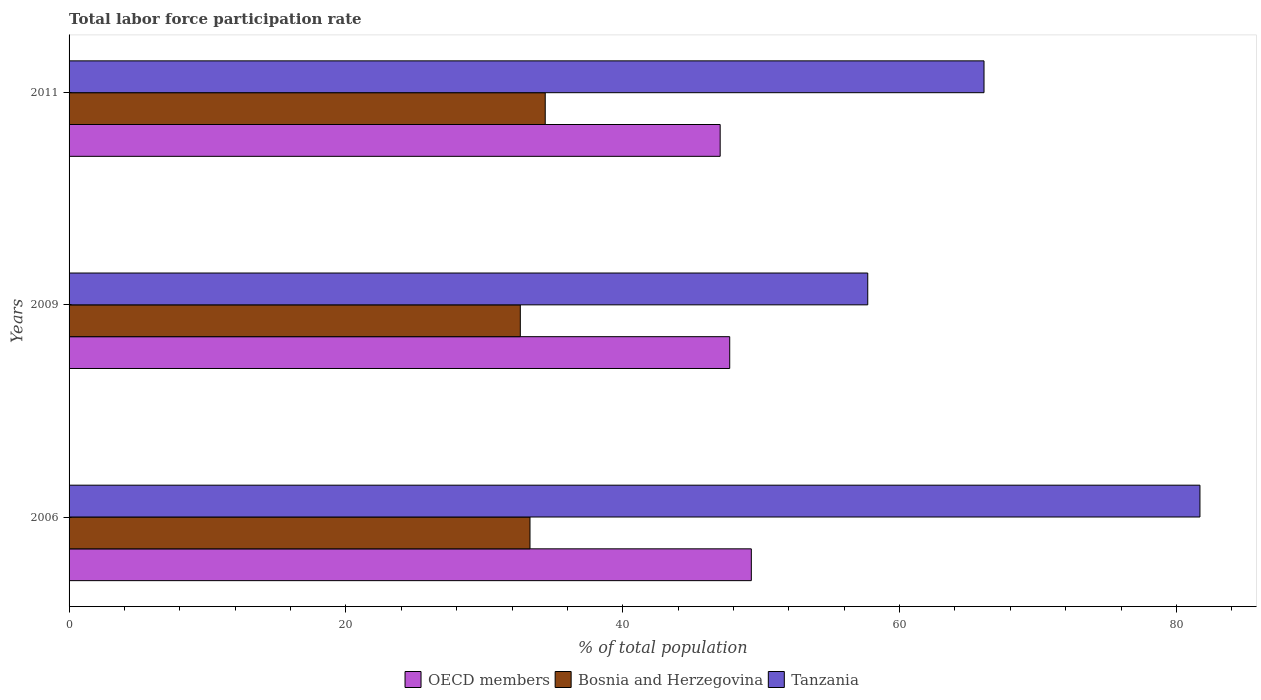How many different coloured bars are there?
Your answer should be very brief. 3. How many bars are there on the 2nd tick from the top?
Provide a succinct answer. 3. What is the label of the 1st group of bars from the top?
Give a very brief answer. 2011. What is the total labor force participation rate in Tanzania in 2006?
Offer a terse response. 81.7. Across all years, what is the maximum total labor force participation rate in Tanzania?
Your answer should be very brief. 81.7. Across all years, what is the minimum total labor force participation rate in Tanzania?
Make the answer very short. 57.7. In which year was the total labor force participation rate in OECD members maximum?
Offer a very short reply. 2006. What is the total total labor force participation rate in Tanzania in the graph?
Offer a terse response. 205.5. What is the difference between the total labor force participation rate in Bosnia and Herzegovina in 2006 and that in 2009?
Make the answer very short. 0.7. What is the difference between the total labor force participation rate in Bosnia and Herzegovina in 2006 and the total labor force participation rate in Tanzania in 2011?
Give a very brief answer. -32.8. What is the average total labor force participation rate in Tanzania per year?
Offer a terse response. 68.5. In the year 2009, what is the difference between the total labor force participation rate in OECD members and total labor force participation rate in Bosnia and Herzegovina?
Provide a short and direct response. 15.13. What is the ratio of the total labor force participation rate in OECD members in 2009 to that in 2011?
Offer a very short reply. 1.01. Is the total labor force participation rate in Bosnia and Herzegovina in 2006 less than that in 2011?
Provide a short and direct response. Yes. Is the difference between the total labor force participation rate in OECD members in 2006 and 2009 greater than the difference between the total labor force participation rate in Bosnia and Herzegovina in 2006 and 2009?
Your response must be concise. Yes. What is the difference between the highest and the second highest total labor force participation rate in Tanzania?
Your response must be concise. 15.6. What is the difference between the highest and the lowest total labor force participation rate in OECD members?
Your answer should be compact. 2.25. Is the sum of the total labor force participation rate in Bosnia and Herzegovina in 2009 and 2011 greater than the maximum total labor force participation rate in OECD members across all years?
Your answer should be very brief. Yes. What does the 1st bar from the top in 2011 represents?
Offer a very short reply. Tanzania. Is it the case that in every year, the sum of the total labor force participation rate in OECD members and total labor force participation rate in Bosnia and Herzegovina is greater than the total labor force participation rate in Tanzania?
Your answer should be very brief. Yes. Are all the bars in the graph horizontal?
Provide a succinct answer. Yes. How many years are there in the graph?
Give a very brief answer. 3. What is the difference between two consecutive major ticks on the X-axis?
Keep it short and to the point. 20. Does the graph contain any zero values?
Your answer should be very brief. No. What is the title of the graph?
Provide a short and direct response. Total labor force participation rate. What is the label or title of the X-axis?
Keep it short and to the point. % of total population. What is the label or title of the Y-axis?
Make the answer very short. Years. What is the % of total population in OECD members in 2006?
Make the answer very short. 49.29. What is the % of total population of Bosnia and Herzegovina in 2006?
Ensure brevity in your answer.  33.3. What is the % of total population in Tanzania in 2006?
Your answer should be compact. 81.7. What is the % of total population in OECD members in 2009?
Provide a succinct answer. 47.73. What is the % of total population in Bosnia and Herzegovina in 2009?
Provide a succinct answer. 32.6. What is the % of total population in Tanzania in 2009?
Make the answer very short. 57.7. What is the % of total population of OECD members in 2011?
Your response must be concise. 47.04. What is the % of total population in Bosnia and Herzegovina in 2011?
Your answer should be very brief. 34.4. What is the % of total population in Tanzania in 2011?
Give a very brief answer. 66.1. Across all years, what is the maximum % of total population of OECD members?
Provide a short and direct response. 49.29. Across all years, what is the maximum % of total population of Bosnia and Herzegovina?
Ensure brevity in your answer.  34.4. Across all years, what is the maximum % of total population in Tanzania?
Make the answer very short. 81.7. Across all years, what is the minimum % of total population in OECD members?
Your response must be concise. 47.04. Across all years, what is the minimum % of total population of Bosnia and Herzegovina?
Provide a short and direct response. 32.6. Across all years, what is the minimum % of total population of Tanzania?
Keep it short and to the point. 57.7. What is the total % of total population in OECD members in the graph?
Provide a succinct answer. 144.06. What is the total % of total population in Bosnia and Herzegovina in the graph?
Give a very brief answer. 100.3. What is the total % of total population of Tanzania in the graph?
Offer a very short reply. 205.5. What is the difference between the % of total population in OECD members in 2006 and that in 2009?
Ensure brevity in your answer.  1.56. What is the difference between the % of total population in Bosnia and Herzegovina in 2006 and that in 2009?
Ensure brevity in your answer.  0.7. What is the difference between the % of total population in OECD members in 2006 and that in 2011?
Offer a very short reply. 2.25. What is the difference between the % of total population in Bosnia and Herzegovina in 2006 and that in 2011?
Offer a very short reply. -1.1. What is the difference between the % of total population of OECD members in 2009 and that in 2011?
Provide a succinct answer. 0.69. What is the difference between the % of total population in Bosnia and Herzegovina in 2009 and that in 2011?
Keep it short and to the point. -1.8. What is the difference between the % of total population of OECD members in 2006 and the % of total population of Bosnia and Herzegovina in 2009?
Make the answer very short. 16.69. What is the difference between the % of total population in OECD members in 2006 and the % of total population in Tanzania in 2009?
Make the answer very short. -8.41. What is the difference between the % of total population in Bosnia and Herzegovina in 2006 and the % of total population in Tanzania in 2009?
Offer a terse response. -24.4. What is the difference between the % of total population in OECD members in 2006 and the % of total population in Bosnia and Herzegovina in 2011?
Make the answer very short. 14.89. What is the difference between the % of total population in OECD members in 2006 and the % of total population in Tanzania in 2011?
Offer a very short reply. -16.81. What is the difference between the % of total population in Bosnia and Herzegovina in 2006 and the % of total population in Tanzania in 2011?
Ensure brevity in your answer.  -32.8. What is the difference between the % of total population in OECD members in 2009 and the % of total population in Bosnia and Herzegovina in 2011?
Your answer should be very brief. 13.33. What is the difference between the % of total population of OECD members in 2009 and the % of total population of Tanzania in 2011?
Provide a succinct answer. -18.37. What is the difference between the % of total population of Bosnia and Herzegovina in 2009 and the % of total population of Tanzania in 2011?
Offer a very short reply. -33.5. What is the average % of total population in OECD members per year?
Your response must be concise. 48.02. What is the average % of total population in Bosnia and Herzegovina per year?
Your response must be concise. 33.43. What is the average % of total population in Tanzania per year?
Make the answer very short. 68.5. In the year 2006, what is the difference between the % of total population in OECD members and % of total population in Bosnia and Herzegovina?
Your response must be concise. 15.99. In the year 2006, what is the difference between the % of total population of OECD members and % of total population of Tanzania?
Give a very brief answer. -32.41. In the year 2006, what is the difference between the % of total population of Bosnia and Herzegovina and % of total population of Tanzania?
Provide a short and direct response. -48.4. In the year 2009, what is the difference between the % of total population in OECD members and % of total population in Bosnia and Herzegovina?
Your answer should be very brief. 15.13. In the year 2009, what is the difference between the % of total population of OECD members and % of total population of Tanzania?
Give a very brief answer. -9.97. In the year 2009, what is the difference between the % of total population of Bosnia and Herzegovina and % of total population of Tanzania?
Make the answer very short. -25.1. In the year 2011, what is the difference between the % of total population in OECD members and % of total population in Bosnia and Herzegovina?
Give a very brief answer. 12.64. In the year 2011, what is the difference between the % of total population of OECD members and % of total population of Tanzania?
Your response must be concise. -19.06. In the year 2011, what is the difference between the % of total population of Bosnia and Herzegovina and % of total population of Tanzania?
Your response must be concise. -31.7. What is the ratio of the % of total population of OECD members in 2006 to that in 2009?
Your answer should be compact. 1.03. What is the ratio of the % of total population of Bosnia and Herzegovina in 2006 to that in 2009?
Your answer should be very brief. 1.02. What is the ratio of the % of total population in Tanzania in 2006 to that in 2009?
Provide a succinct answer. 1.42. What is the ratio of the % of total population of OECD members in 2006 to that in 2011?
Provide a succinct answer. 1.05. What is the ratio of the % of total population of Bosnia and Herzegovina in 2006 to that in 2011?
Your answer should be compact. 0.97. What is the ratio of the % of total population of Tanzania in 2006 to that in 2011?
Offer a terse response. 1.24. What is the ratio of the % of total population of OECD members in 2009 to that in 2011?
Offer a very short reply. 1.01. What is the ratio of the % of total population of Bosnia and Herzegovina in 2009 to that in 2011?
Offer a terse response. 0.95. What is the ratio of the % of total population of Tanzania in 2009 to that in 2011?
Your answer should be very brief. 0.87. What is the difference between the highest and the second highest % of total population in OECD members?
Provide a succinct answer. 1.56. What is the difference between the highest and the second highest % of total population of Bosnia and Herzegovina?
Your answer should be very brief. 1.1. What is the difference between the highest and the lowest % of total population of OECD members?
Ensure brevity in your answer.  2.25. What is the difference between the highest and the lowest % of total population of Tanzania?
Your response must be concise. 24. 